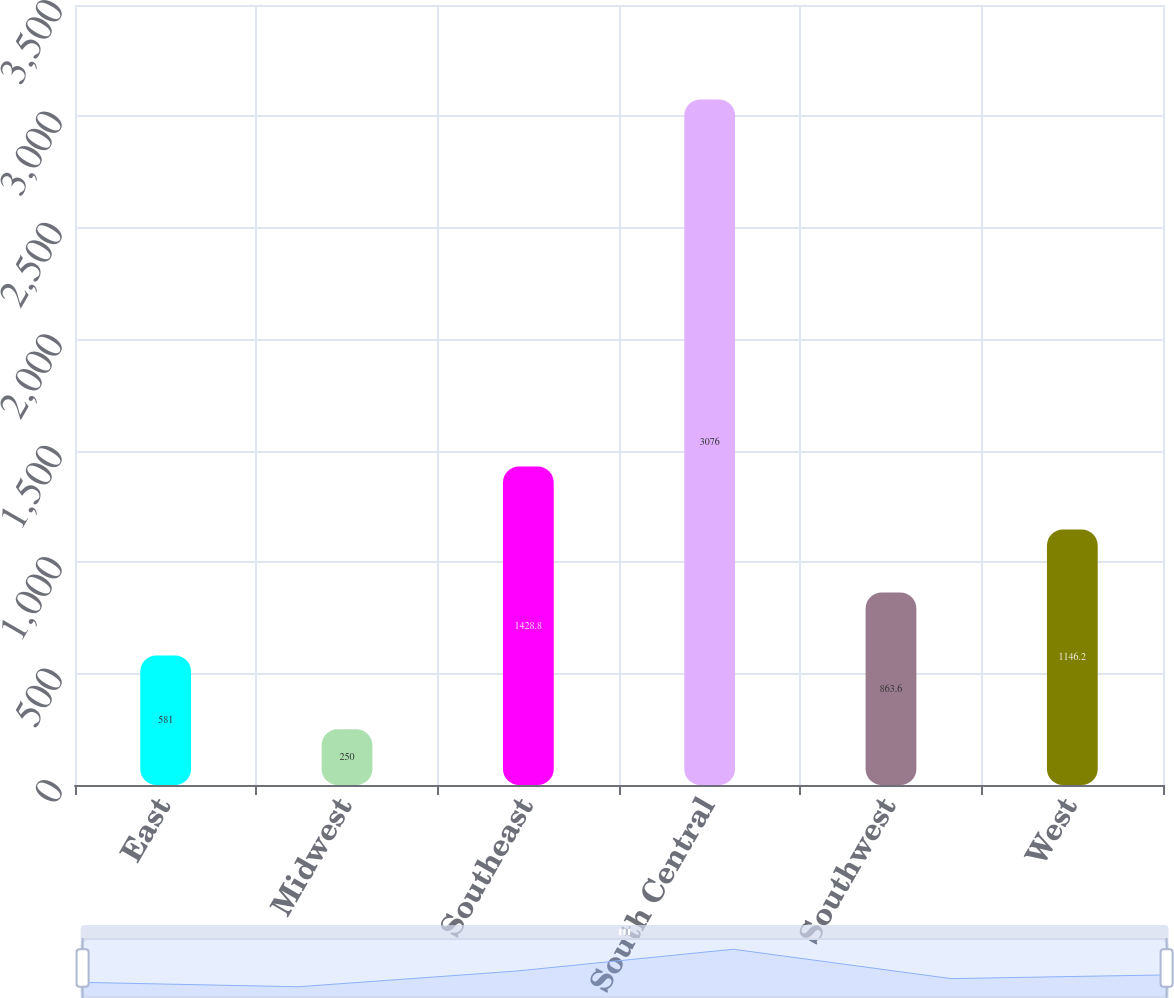<chart> <loc_0><loc_0><loc_500><loc_500><bar_chart><fcel>East<fcel>Midwest<fcel>Southeast<fcel>South Central<fcel>Southwest<fcel>West<nl><fcel>581<fcel>250<fcel>1428.8<fcel>3076<fcel>863.6<fcel>1146.2<nl></chart> 